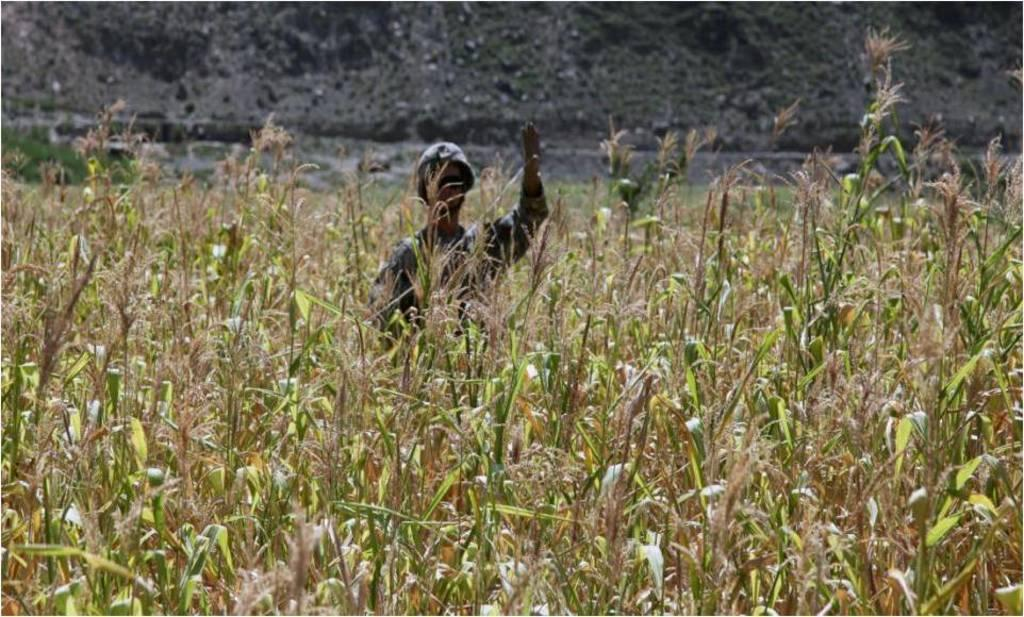What is the main subject of the image? There is a person standing in the image. What is the person's immediate environment like? The person is surrounded by plants. What can be seen in the distance in the image? There is a mountain in the background of the image. How many bricks are visible in the image? There are no bricks present in the image. What type of footwear is the person wearing in the image? The provided facts do not mention the person's footwear, so we cannot determine what type they are wearing. 